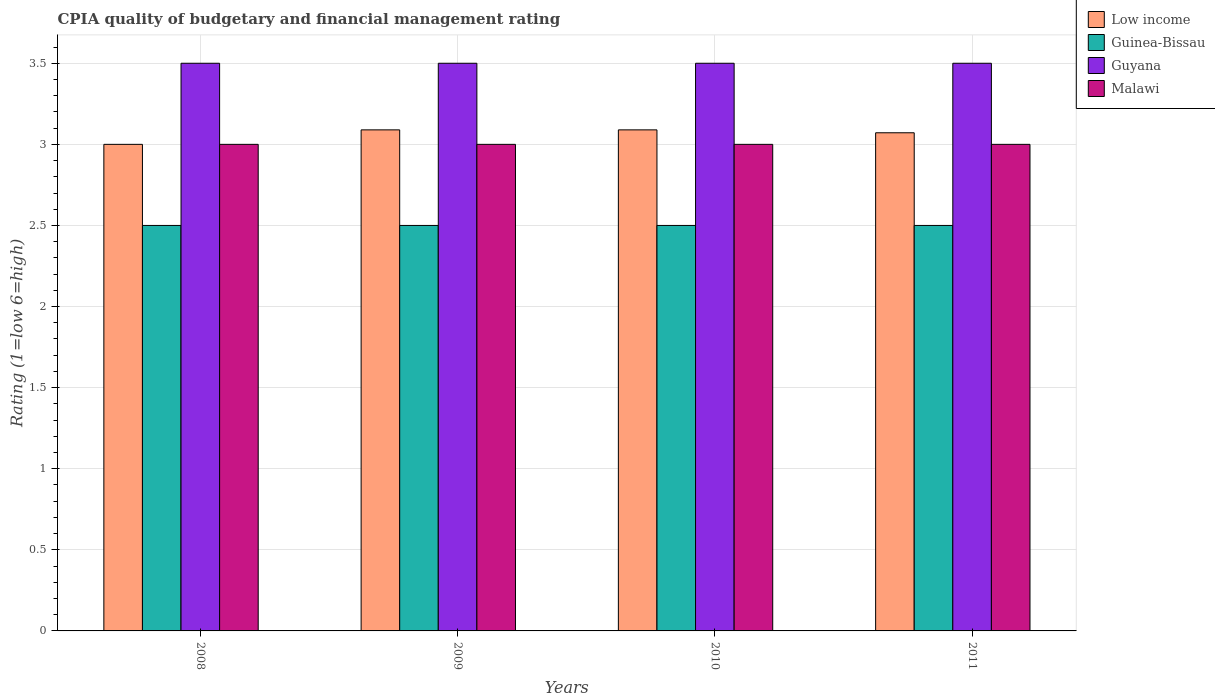How many different coloured bars are there?
Your answer should be very brief. 4. Are the number of bars on each tick of the X-axis equal?
Make the answer very short. Yes. In how many cases, is the number of bars for a given year not equal to the number of legend labels?
Offer a very short reply. 0. What is the CPIA rating in Malawi in 2011?
Give a very brief answer. 3. Across all years, what is the minimum CPIA rating in Guyana?
Ensure brevity in your answer.  3.5. In which year was the CPIA rating in Malawi maximum?
Your response must be concise. 2008. What is the difference between the CPIA rating in Malawi in 2008 and that in 2009?
Offer a very short reply. 0. In the year 2011, what is the difference between the CPIA rating in Guinea-Bissau and CPIA rating in Malawi?
Give a very brief answer. -0.5. What is the ratio of the CPIA rating in Low income in 2008 to that in 2009?
Your answer should be compact. 0.97. Is the CPIA rating in Guinea-Bissau in 2008 less than that in 2011?
Offer a very short reply. No. What is the difference between the highest and the second highest CPIA rating in Malawi?
Provide a succinct answer. 0. Is the sum of the CPIA rating in Low income in 2009 and 2010 greater than the maximum CPIA rating in Guyana across all years?
Offer a terse response. Yes. What does the 3rd bar from the right in 2011 represents?
Ensure brevity in your answer.  Guinea-Bissau. Is it the case that in every year, the sum of the CPIA rating in Guinea-Bissau and CPIA rating in Low income is greater than the CPIA rating in Guyana?
Offer a very short reply. Yes. How many years are there in the graph?
Your response must be concise. 4. What is the difference between two consecutive major ticks on the Y-axis?
Make the answer very short. 0.5. Where does the legend appear in the graph?
Ensure brevity in your answer.  Top right. How many legend labels are there?
Give a very brief answer. 4. How are the legend labels stacked?
Provide a short and direct response. Vertical. What is the title of the graph?
Offer a terse response. CPIA quality of budgetary and financial management rating. Does "Caribbean small states" appear as one of the legend labels in the graph?
Give a very brief answer. No. What is the label or title of the X-axis?
Provide a short and direct response. Years. What is the label or title of the Y-axis?
Make the answer very short. Rating (1=low 6=high). What is the Rating (1=low 6=high) in Low income in 2008?
Your response must be concise. 3. What is the Rating (1=low 6=high) in Guinea-Bissau in 2008?
Make the answer very short. 2.5. What is the Rating (1=low 6=high) of Malawi in 2008?
Provide a succinct answer. 3. What is the Rating (1=low 6=high) of Low income in 2009?
Offer a terse response. 3.09. What is the Rating (1=low 6=high) in Guinea-Bissau in 2009?
Your response must be concise. 2.5. What is the Rating (1=low 6=high) of Guyana in 2009?
Offer a terse response. 3.5. What is the Rating (1=low 6=high) of Low income in 2010?
Your answer should be very brief. 3.09. What is the Rating (1=low 6=high) of Guinea-Bissau in 2010?
Ensure brevity in your answer.  2.5. What is the Rating (1=low 6=high) of Malawi in 2010?
Provide a succinct answer. 3. What is the Rating (1=low 6=high) of Low income in 2011?
Provide a succinct answer. 3.07. What is the Rating (1=low 6=high) of Guinea-Bissau in 2011?
Provide a succinct answer. 2.5. What is the Rating (1=low 6=high) of Malawi in 2011?
Provide a short and direct response. 3. Across all years, what is the maximum Rating (1=low 6=high) of Low income?
Ensure brevity in your answer.  3.09. Across all years, what is the maximum Rating (1=low 6=high) in Guyana?
Make the answer very short. 3.5. Across all years, what is the minimum Rating (1=low 6=high) in Guinea-Bissau?
Keep it short and to the point. 2.5. Across all years, what is the minimum Rating (1=low 6=high) of Guyana?
Offer a very short reply. 3.5. Across all years, what is the minimum Rating (1=low 6=high) in Malawi?
Keep it short and to the point. 3. What is the total Rating (1=low 6=high) of Low income in the graph?
Provide a succinct answer. 12.25. What is the total Rating (1=low 6=high) of Guyana in the graph?
Your answer should be compact. 14. What is the difference between the Rating (1=low 6=high) in Low income in 2008 and that in 2009?
Offer a very short reply. -0.09. What is the difference between the Rating (1=low 6=high) of Guyana in 2008 and that in 2009?
Provide a succinct answer. 0. What is the difference between the Rating (1=low 6=high) in Malawi in 2008 and that in 2009?
Make the answer very short. 0. What is the difference between the Rating (1=low 6=high) in Low income in 2008 and that in 2010?
Your answer should be compact. -0.09. What is the difference between the Rating (1=low 6=high) of Guinea-Bissau in 2008 and that in 2010?
Your answer should be compact. 0. What is the difference between the Rating (1=low 6=high) of Low income in 2008 and that in 2011?
Offer a terse response. -0.07. What is the difference between the Rating (1=low 6=high) in Guinea-Bissau in 2008 and that in 2011?
Your answer should be very brief. 0. What is the difference between the Rating (1=low 6=high) in Malawi in 2008 and that in 2011?
Give a very brief answer. 0. What is the difference between the Rating (1=low 6=high) of Guinea-Bissau in 2009 and that in 2010?
Ensure brevity in your answer.  0. What is the difference between the Rating (1=low 6=high) of Malawi in 2009 and that in 2010?
Your response must be concise. 0. What is the difference between the Rating (1=low 6=high) of Low income in 2009 and that in 2011?
Your response must be concise. 0.02. What is the difference between the Rating (1=low 6=high) of Guinea-Bissau in 2009 and that in 2011?
Your answer should be very brief. 0. What is the difference between the Rating (1=low 6=high) of Guyana in 2009 and that in 2011?
Keep it short and to the point. 0. What is the difference between the Rating (1=low 6=high) in Low income in 2010 and that in 2011?
Offer a terse response. 0.02. What is the difference between the Rating (1=low 6=high) of Guyana in 2010 and that in 2011?
Provide a short and direct response. 0. What is the difference between the Rating (1=low 6=high) in Malawi in 2010 and that in 2011?
Offer a terse response. 0. What is the difference between the Rating (1=low 6=high) in Low income in 2008 and the Rating (1=low 6=high) in Malawi in 2009?
Offer a terse response. 0. What is the difference between the Rating (1=low 6=high) in Guinea-Bissau in 2008 and the Rating (1=low 6=high) in Guyana in 2009?
Make the answer very short. -1. What is the difference between the Rating (1=low 6=high) of Guinea-Bissau in 2008 and the Rating (1=low 6=high) of Malawi in 2009?
Your response must be concise. -0.5. What is the difference between the Rating (1=low 6=high) in Low income in 2008 and the Rating (1=low 6=high) in Guyana in 2010?
Ensure brevity in your answer.  -0.5. What is the difference between the Rating (1=low 6=high) in Guinea-Bissau in 2008 and the Rating (1=low 6=high) in Malawi in 2010?
Give a very brief answer. -0.5. What is the difference between the Rating (1=low 6=high) in Guyana in 2008 and the Rating (1=low 6=high) in Malawi in 2010?
Keep it short and to the point. 0.5. What is the difference between the Rating (1=low 6=high) in Low income in 2008 and the Rating (1=low 6=high) in Guinea-Bissau in 2011?
Keep it short and to the point. 0.5. What is the difference between the Rating (1=low 6=high) of Low income in 2008 and the Rating (1=low 6=high) of Malawi in 2011?
Keep it short and to the point. 0. What is the difference between the Rating (1=low 6=high) in Guinea-Bissau in 2008 and the Rating (1=low 6=high) in Guyana in 2011?
Ensure brevity in your answer.  -1. What is the difference between the Rating (1=low 6=high) in Guinea-Bissau in 2008 and the Rating (1=low 6=high) in Malawi in 2011?
Your answer should be very brief. -0.5. What is the difference between the Rating (1=low 6=high) in Guyana in 2008 and the Rating (1=low 6=high) in Malawi in 2011?
Make the answer very short. 0.5. What is the difference between the Rating (1=low 6=high) in Low income in 2009 and the Rating (1=low 6=high) in Guinea-Bissau in 2010?
Make the answer very short. 0.59. What is the difference between the Rating (1=low 6=high) of Low income in 2009 and the Rating (1=low 6=high) of Guyana in 2010?
Ensure brevity in your answer.  -0.41. What is the difference between the Rating (1=low 6=high) in Low income in 2009 and the Rating (1=low 6=high) in Malawi in 2010?
Provide a succinct answer. 0.09. What is the difference between the Rating (1=low 6=high) of Guinea-Bissau in 2009 and the Rating (1=low 6=high) of Guyana in 2010?
Your response must be concise. -1. What is the difference between the Rating (1=low 6=high) of Guinea-Bissau in 2009 and the Rating (1=low 6=high) of Malawi in 2010?
Offer a terse response. -0.5. What is the difference between the Rating (1=low 6=high) in Low income in 2009 and the Rating (1=low 6=high) in Guinea-Bissau in 2011?
Offer a terse response. 0.59. What is the difference between the Rating (1=low 6=high) of Low income in 2009 and the Rating (1=low 6=high) of Guyana in 2011?
Provide a short and direct response. -0.41. What is the difference between the Rating (1=low 6=high) of Low income in 2009 and the Rating (1=low 6=high) of Malawi in 2011?
Ensure brevity in your answer.  0.09. What is the difference between the Rating (1=low 6=high) of Guinea-Bissau in 2009 and the Rating (1=low 6=high) of Guyana in 2011?
Offer a terse response. -1. What is the difference between the Rating (1=low 6=high) in Low income in 2010 and the Rating (1=low 6=high) in Guinea-Bissau in 2011?
Your response must be concise. 0.59. What is the difference between the Rating (1=low 6=high) of Low income in 2010 and the Rating (1=low 6=high) of Guyana in 2011?
Offer a terse response. -0.41. What is the difference between the Rating (1=low 6=high) of Low income in 2010 and the Rating (1=low 6=high) of Malawi in 2011?
Give a very brief answer. 0.09. What is the difference between the Rating (1=low 6=high) of Guinea-Bissau in 2010 and the Rating (1=low 6=high) of Malawi in 2011?
Your answer should be compact. -0.5. What is the difference between the Rating (1=low 6=high) of Guyana in 2010 and the Rating (1=low 6=high) of Malawi in 2011?
Your answer should be very brief. 0.5. What is the average Rating (1=low 6=high) of Low income per year?
Offer a very short reply. 3.06. In the year 2008, what is the difference between the Rating (1=low 6=high) of Low income and Rating (1=low 6=high) of Guinea-Bissau?
Keep it short and to the point. 0.5. In the year 2008, what is the difference between the Rating (1=low 6=high) in Low income and Rating (1=low 6=high) in Guyana?
Give a very brief answer. -0.5. In the year 2008, what is the difference between the Rating (1=low 6=high) in Guinea-Bissau and Rating (1=low 6=high) in Malawi?
Your answer should be very brief. -0.5. In the year 2008, what is the difference between the Rating (1=low 6=high) of Guyana and Rating (1=low 6=high) of Malawi?
Your answer should be very brief. 0.5. In the year 2009, what is the difference between the Rating (1=low 6=high) in Low income and Rating (1=low 6=high) in Guinea-Bissau?
Keep it short and to the point. 0.59. In the year 2009, what is the difference between the Rating (1=low 6=high) of Low income and Rating (1=low 6=high) of Guyana?
Your answer should be compact. -0.41. In the year 2009, what is the difference between the Rating (1=low 6=high) in Low income and Rating (1=low 6=high) in Malawi?
Give a very brief answer. 0.09. In the year 2009, what is the difference between the Rating (1=low 6=high) of Guinea-Bissau and Rating (1=low 6=high) of Malawi?
Your answer should be compact. -0.5. In the year 2010, what is the difference between the Rating (1=low 6=high) in Low income and Rating (1=low 6=high) in Guinea-Bissau?
Ensure brevity in your answer.  0.59. In the year 2010, what is the difference between the Rating (1=low 6=high) in Low income and Rating (1=low 6=high) in Guyana?
Your response must be concise. -0.41. In the year 2010, what is the difference between the Rating (1=low 6=high) of Low income and Rating (1=low 6=high) of Malawi?
Your answer should be compact. 0.09. In the year 2010, what is the difference between the Rating (1=low 6=high) of Guinea-Bissau and Rating (1=low 6=high) of Malawi?
Offer a very short reply. -0.5. In the year 2010, what is the difference between the Rating (1=low 6=high) in Guyana and Rating (1=low 6=high) in Malawi?
Make the answer very short. 0.5. In the year 2011, what is the difference between the Rating (1=low 6=high) in Low income and Rating (1=low 6=high) in Guinea-Bissau?
Provide a short and direct response. 0.57. In the year 2011, what is the difference between the Rating (1=low 6=high) in Low income and Rating (1=low 6=high) in Guyana?
Offer a very short reply. -0.43. In the year 2011, what is the difference between the Rating (1=low 6=high) in Low income and Rating (1=low 6=high) in Malawi?
Make the answer very short. 0.07. In the year 2011, what is the difference between the Rating (1=low 6=high) in Guinea-Bissau and Rating (1=low 6=high) in Guyana?
Make the answer very short. -1. What is the ratio of the Rating (1=low 6=high) in Low income in 2008 to that in 2009?
Keep it short and to the point. 0.97. What is the ratio of the Rating (1=low 6=high) in Guinea-Bissau in 2008 to that in 2009?
Your answer should be compact. 1. What is the ratio of the Rating (1=low 6=high) of Low income in 2008 to that in 2010?
Your answer should be compact. 0.97. What is the ratio of the Rating (1=low 6=high) of Guinea-Bissau in 2008 to that in 2010?
Your response must be concise. 1. What is the ratio of the Rating (1=low 6=high) of Guyana in 2008 to that in 2010?
Offer a terse response. 1. What is the ratio of the Rating (1=low 6=high) in Malawi in 2008 to that in 2010?
Offer a terse response. 1. What is the ratio of the Rating (1=low 6=high) in Low income in 2008 to that in 2011?
Keep it short and to the point. 0.98. What is the ratio of the Rating (1=low 6=high) in Guinea-Bissau in 2008 to that in 2011?
Give a very brief answer. 1. What is the ratio of the Rating (1=low 6=high) in Guyana in 2008 to that in 2011?
Offer a terse response. 1. What is the ratio of the Rating (1=low 6=high) of Low income in 2009 to that in 2010?
Provide a succinct answer. 1. What is the ratio of the Rating (1=low 6=high) in Guinea-Bissau in 2009 to that in 2010?
Provide a succinct answer. 1. What is the ratio of the Rating (1=low 6=high) of Guinea-Bissau in 2009 to that in 2011?
Provide a short and direct response. 1. What is the ratio of the Rating (1=low 6=high) in Guyana in 2009 to that in 2011?
Make the answer very short. 1. What is the ratio of the Rating (1=low 6=high) of Low income in 2010 to that in 2011?
Provide a short and direct response. 1.01. What is the ratio of the Rating (1=low 6=high) in Guyana in 2010 to that in 2011?
Provide a succinct answer. 1. What is the ratio of the Rating (1=low 6=high) of Malawi in 2010 to that in 2011?
Offer a terse response. 1. What is the difference between the highest and the second highest Rating (1=low 6=high) of Low income?
Your response must be concise. 0. What is the difference between the highest and the lowest Rating (1=low 6=high) in Low income?
Provide a succinct answer. 0.09. 